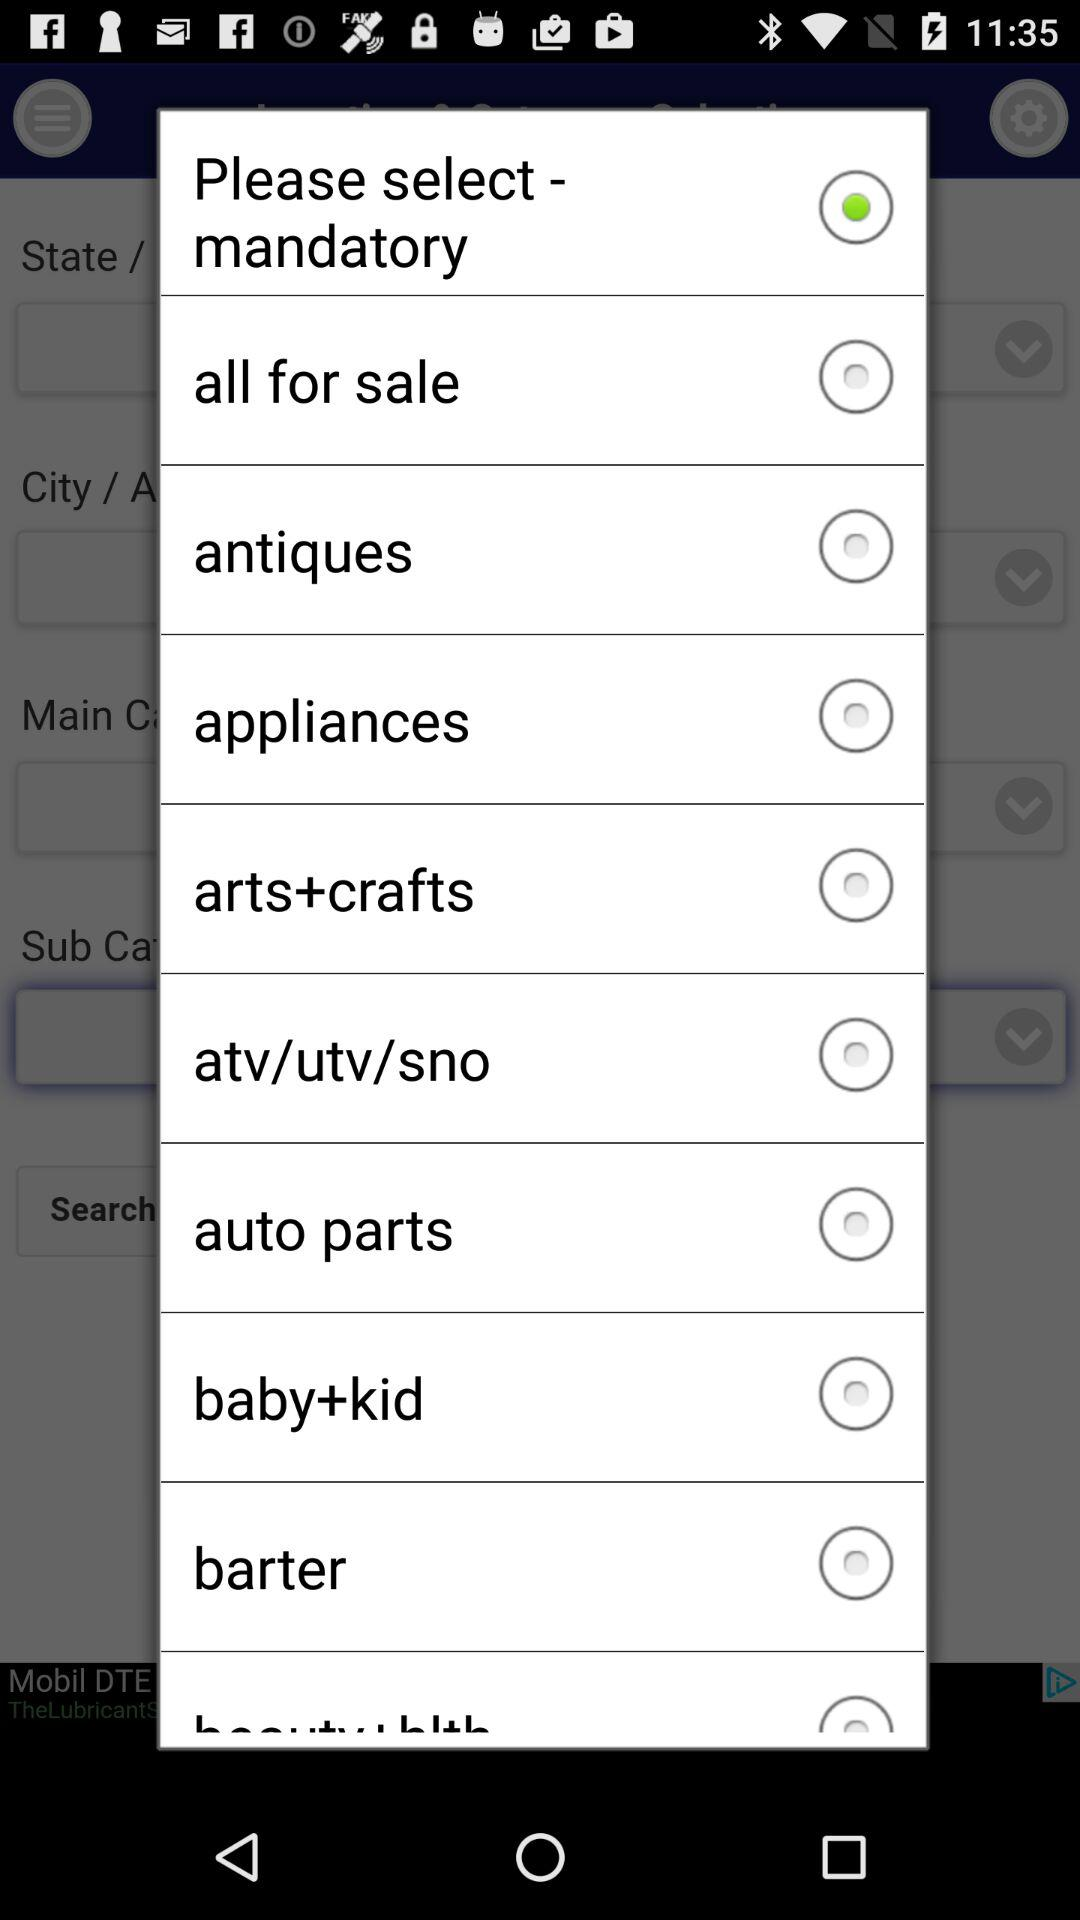What option is selected?
Answer the question using a single word or phrase. The selected option is "Please select-mandatory." 